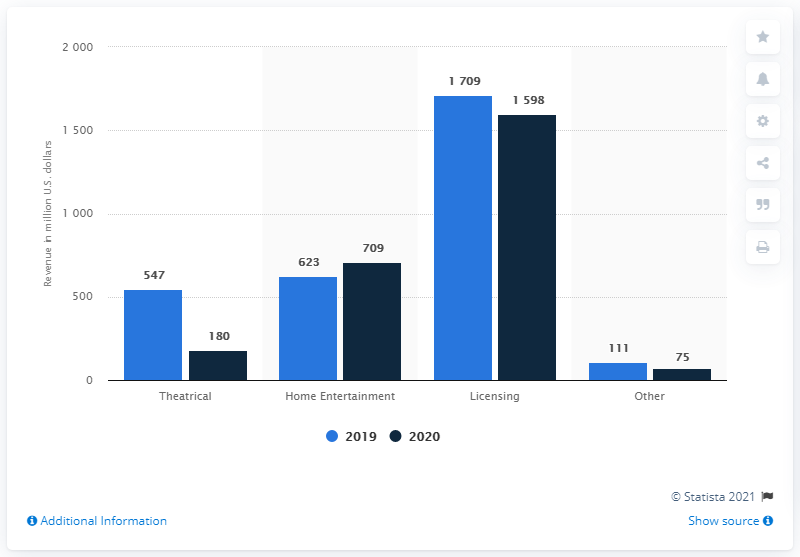Draw attention to some important aspects in this diagram. ViacomCBS' home entertainment revenue in the year before was 623... In 2020, ViacomCBS's box office sales were approximately 180 million dollars. In 2020, ViacomCBS generated approximately 709 million in revenue. 